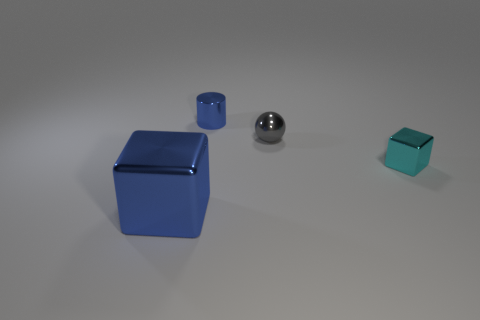Subtract all green cylinders. Subtract all gray blocks. How many cylinders are left? 1 Subtract all cyan spheres. How many red cylinders are left? 0 Add 4 tiny blues. How many cyans exist? 0 Subtract all small cyan rubber cylinders. Subtract all large metal blocks. How many objects are left? 3 Add 4 small gray metal objects. How many small gray metal objects are left? 5 Add 4 small blocks. How many small blocks exist? 5 Add 3 green rubber cylinders. How many objects exist? 7 Subtract all cyan cubes. How many cubes are left? 1 Subtract 0 purple cylinders. How many objects are left? 4 Subtract all cylinders. How many objects are left? 3 